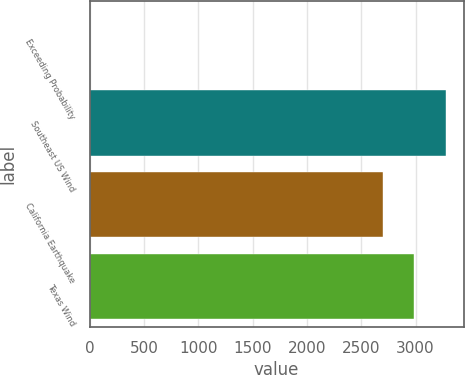Convert chart. <chart><loc_0><loc_0><loc_500><loc_500><bar_chart><fcel>Exceeding Probability<fcel>Southeast US Wind<fcel>California Earthquake<fcel>Texas Wind<nl><fcel>0.1<fcel>3277.38<fcel>2701<fcel>2989.19<nl></chart> 